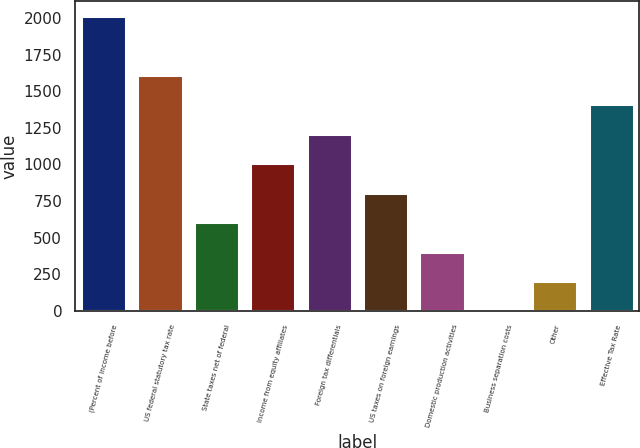Convert chart. <chart><loc_0><loc_0><loc_500><loc_500><bar_chart><fcel>(Percent of income before<fcel>US federal statutory tax rate<fcel>State taxes net of federal<fcel>Income from equity affiliates<fcel>Foreign tax differentials<fcel>US taxes on foreign earnings<fcel>Domestic production activities<fcel>Business separation costs<fcel>Other<fcel>Effective Tax Rate<nl><fcel>2015<fcel>1612.04<fcel>604.64<fcel>1007.6<fcel>1209.08<fcel>806.12<fcel>403.16<fcel>0.2<fcel>201.68<fcel>1410.56<nl></chart> 